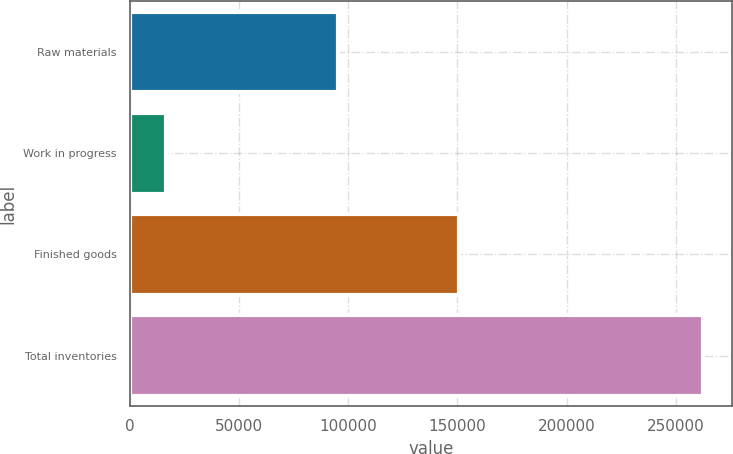<chart> <loc_0><loc_0><loc_500><loc_500><bar_chart><fcel>Raw materials<fcel>Work in progress<fcel>Finished goods<fcel>Total inventories<nl><fcel>95430<fcel>16585<fcel>150667<fcel>262682<nl></chart> 